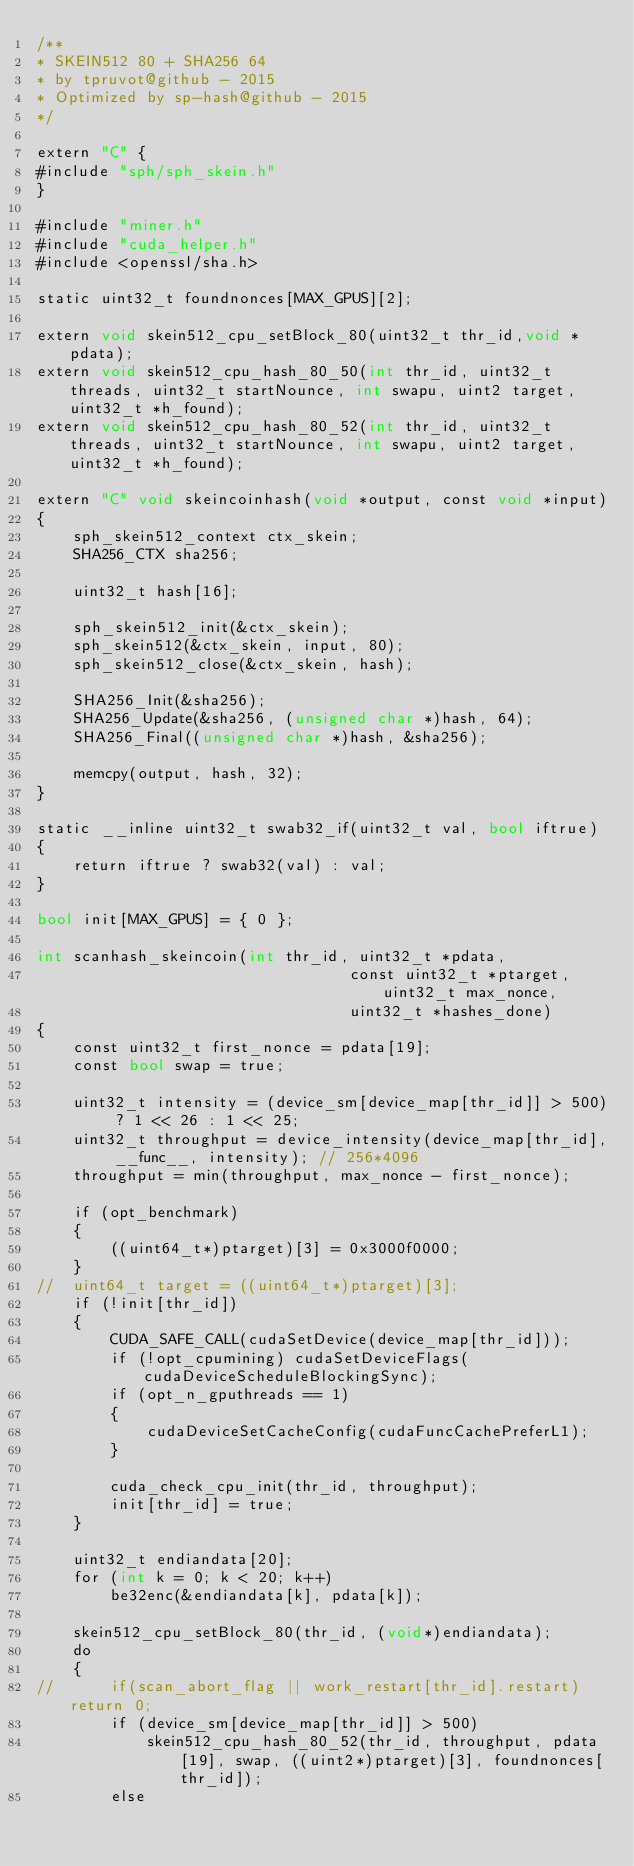Convert code to text. <code><loc_0><loc_0><loc_500><loc_500><_Cuda_>/**
* SKEIN512 80 + SHA256 64
* by tpruvot@github - 2015
* Optimized by sp-hash@github - 2015
*/

extern "C" {
#include "sph/sph_skein.h"
}

#include "miner.h"
#include "cuda_helper.h"
#include <openssl/sha.h>
 
static uint32_t foundnonces[MAX_GPUS][2];

extern void skein512_cpu_setBlock_80(uint32_t thr_id,void *pdata);
extern void skein512_cpu_hash_80_50(int thr_id, uint32_t threads, uint32_t startNounce, int swapu, uint2 target, uint32_t *h_found);
extern void skein512_cpu_hash_80_52(int thr_id, uint32_t threads, uint32_t startNounce, int swapu, uint2 target, uint32_t *h_found);

extern "C" void skeincoinhash(void *output, const void *input)
{
	sph_skein512_context ctx_skein;
	SHA256_CTX sha256;

	uint32_t hash[16];

	sph_skein512_init(&ctx_skein);
	sph_skein512(&ctx_skein, input, 80);
	sph_skein512_close(&ctx_skein, hash);

	SHA256_Init(&sha256);
	SHA256_Update(&sha256, (unsigned char *)hash, 64);
	SHA256_Final((unsigned char *)hash, &sha256);

	memcpy(output, hash, 32);
}

static __inline uint32_t swab32_if(uint32_t val, bool iftrue)
{
	return iftrue ? swab32(val) : val;
}

bool init[MAX_GPUS] = { 0 };

int scanhash_skeincoin(int thr_id, uint32_t *pdata,
								  const uint32_t *ptarget, uint32_t max_nonce,
								  uint32_t *hashes_done)
{
	const uint32_t first_nonce = pdata[19];
	const bool swap = true;

	uint32_t intensity = (device_sm[device_map[thr_id]] > 500) ? 1 << 26 : 1 << 25;
	uint32_t throughput = device_intensity(device_map[thr_id], __func__, intensity); // 256*4096
	throughput = min(throughput, max_nonce - first_nonce);

	if (opt_benchmark)
	{
		((uint64_t*)ptarget)[3] = 0x3000f0000;
	}
//	uint64_t target = ((uint64_t*)ptarget)[3];
	if (!init[thr_id])
	{
		CUDA_SAFE_CALL(cudaSetDevice(device_map[thr_id]));
		if (!opt_cpumining) cudaSetDeviceFlags(cudaDeviceScheduleBlockingSync);
		if (opt_n_gputhreads == 1)
		{
			cudaDeviceSetCacheConfig(cudaFuncCachePreferL1);
		}

		cuda_check_cpu_init(thr_id, throughput);
		init[thr_id] = true;
	}

	uint32_t endiandata[20];
	for (int k = 0; k < 20; k++)
		be32enc(&endiandata[k], pdata[k]);

	skein512_cpu_setBlock_80(thr_id, (void*)endiandata);
	do
	{
//		if(scan_abort_flag || work_restart[thr_id].restart) return 0;
		if (device_sm[device_map[thr_id]] > 500)
			skein512_cpu_hash_80_52(thr_id, throughput, pdata[19], swap, ((uint2*)ptarget)[3], foundnonces[thr_id]);
		else</code> 